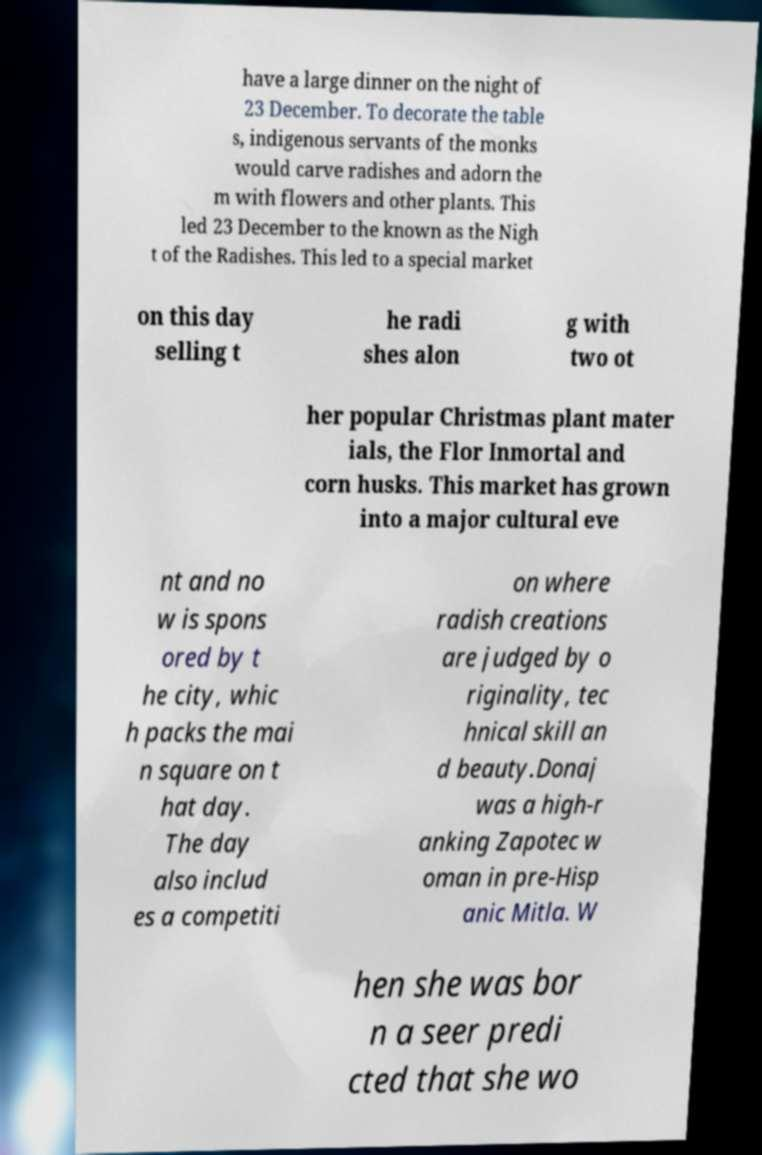What messages or text are displayed in this image? I need them in a readable, typed format. have a large dinner on the night of 23 December. To decorate the table s, indigenous servants of the monks would carve radishes and adorn the m with flowers and other plants. This led 23 December to the known as the Nigh t of the Radishes. This led to a special market on this day selling t he radi shes alon g with two ot her popular Christmas plant mater ials, the Flor Inmortal and corn husks. This market has grown into a major cultural eve nt and no w is spons ored by t he city, whic h packs the mai n square on t hat day. The day also includ es a competiti on where radish creations are judged by o riginality, tec hnical skill an d beauty.Donaj was a high-r anking Zapotec w oman in pre-Hisp anic Mitla. W hen she was bor n a seer predi cted that she wo 